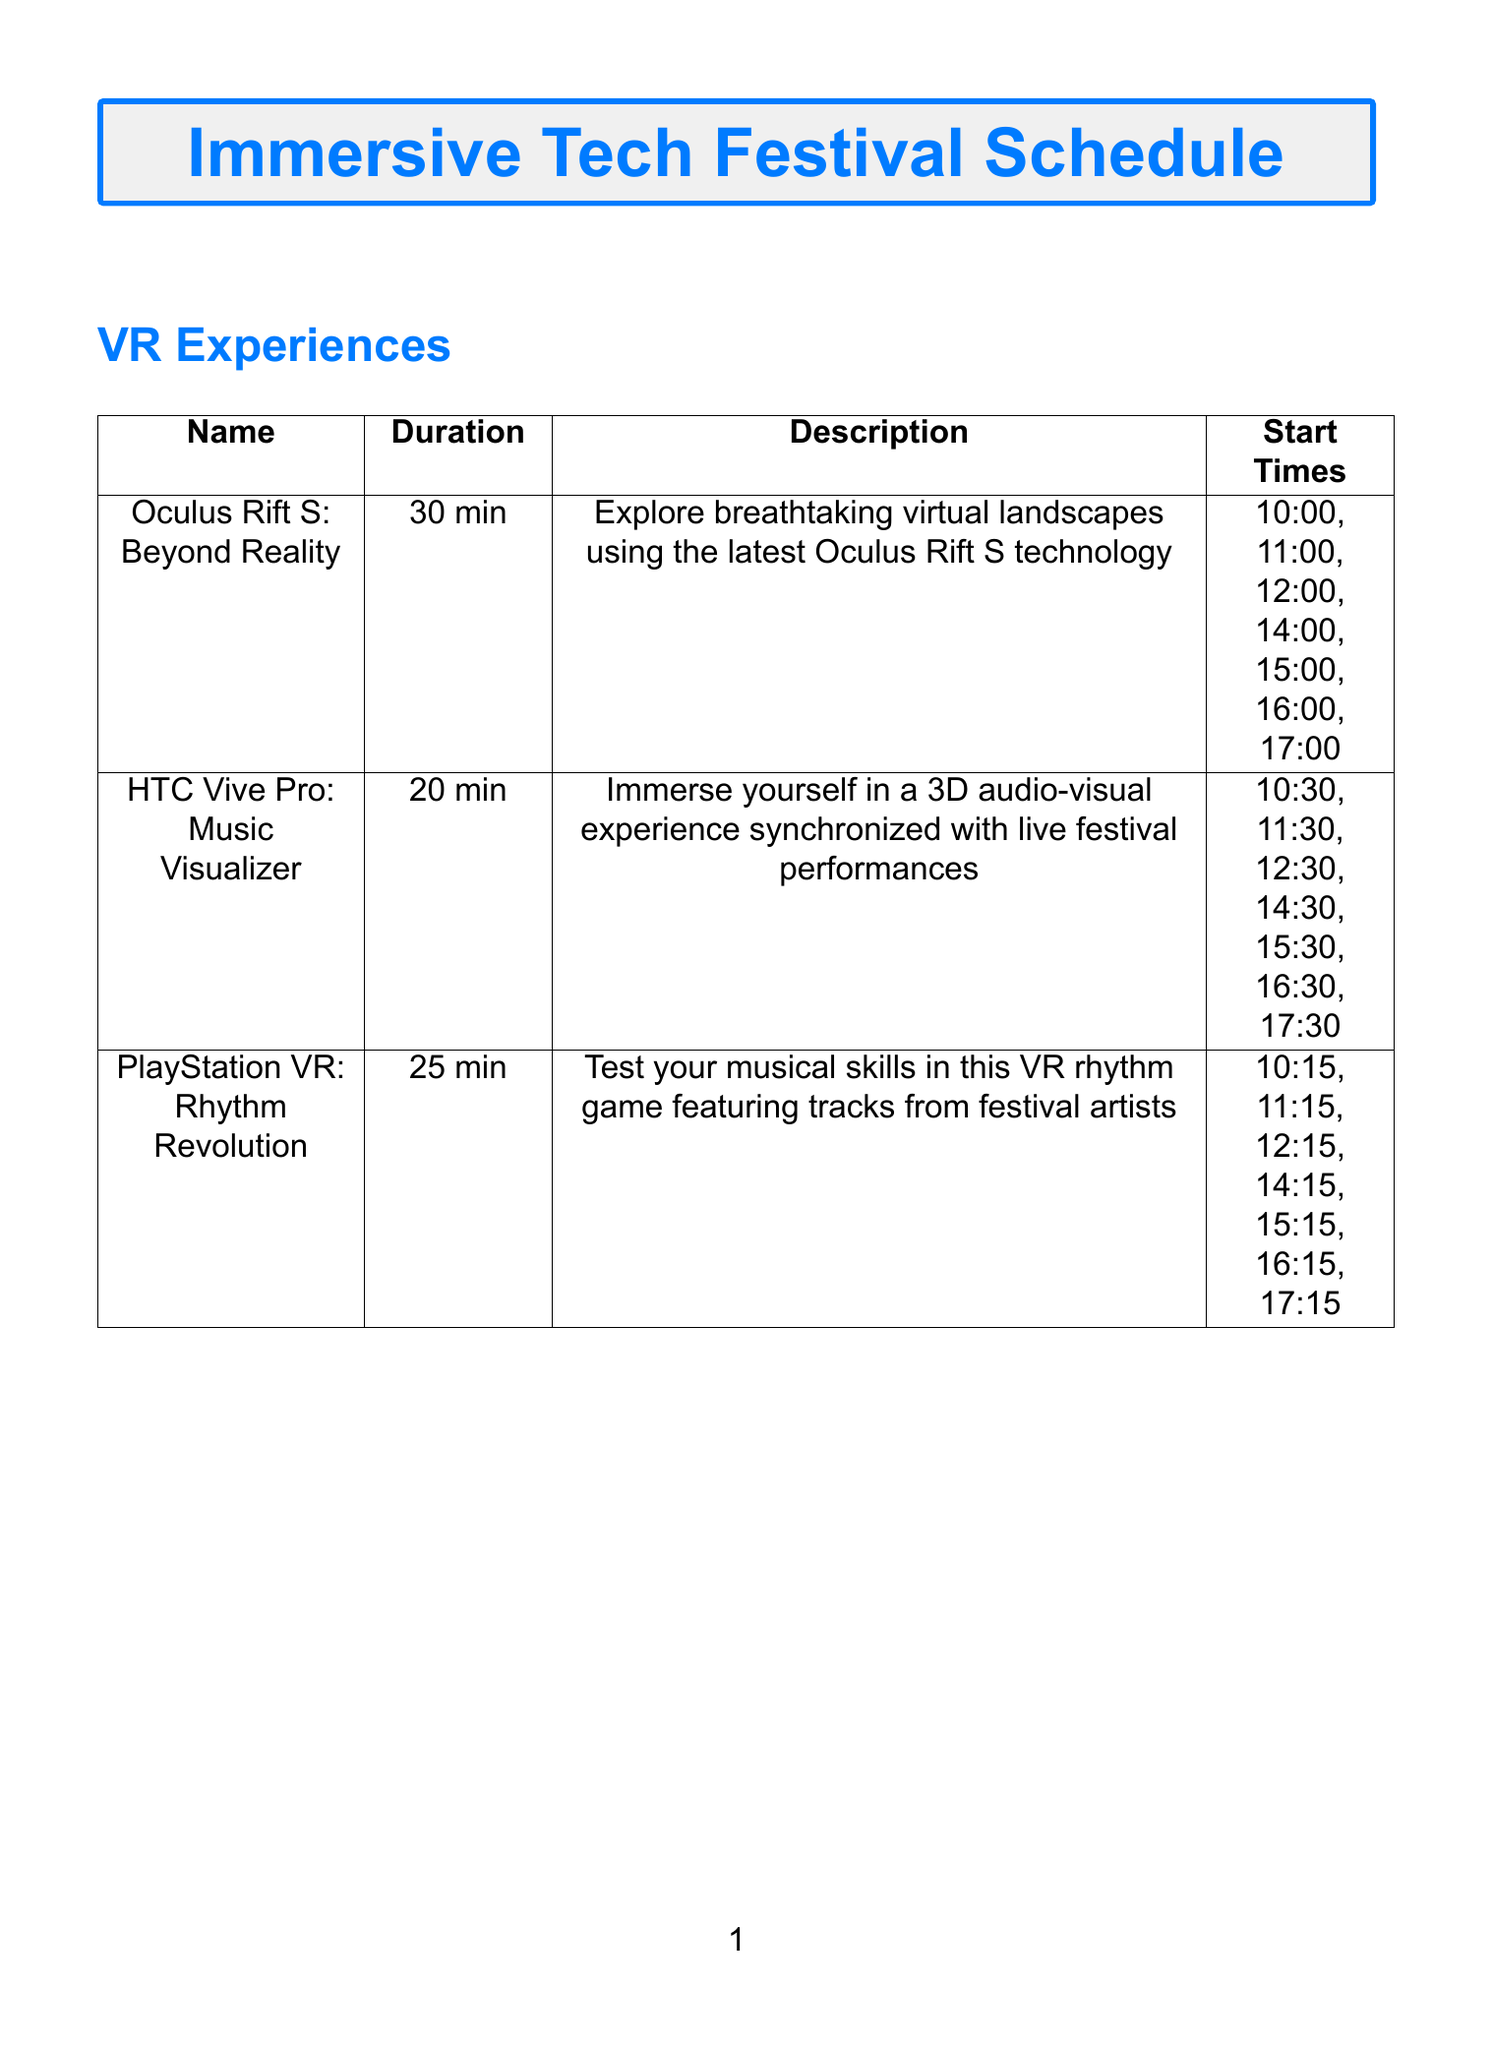What is the first VR experience listed? The first VR experience in the document is listed at the top of the "VR Experiences" section, which is "Oculus Rift S: Beyond Reality".
Answer: Oculus Rift S: Beyond Reality How long does the "HTC Vive Pro: Music Visualizer" last? The duration for the “HTC Vive Pro: Music Visualizer” is mentioned clearly in the respective table under the "Duration" column.
Answer: 20 min What time does the "Festival GO" AR game start? The start time for the "Festival GO" AR game is specified at the beginning of the description.
Answer: 10:00 What is the capacity for the "Stage Invaders" AR game? The capacity is noted in the table, which lists how many participants can join the "Stage Invaders" session.
Answer: 8 How many VR experiences have start times at 15:00? By counting the start times listed in the "VR Experiences" section for the specific hour of 15:00, the total can be deduced.
Answer: 3 What is the name of the special event scheduled at 20:00? The only special event start time at 20:00 is explicitly stated in the "Special Events" section.
Answer: VR Concert: The Glitch Mob Live How many different AR games have sessions starting at 11:45? The "AR Games" section lists each session and the times, helping to identify how many games start at that time.
Answer: 2 Which VR experience has the shortest duration? By comparing the durations listed for each VR experience in the table, the shortest can be determined.
Answer: HTC Vive Pro: Music Visualizer What technology is used in the "Magic Leap: Soundscape Sculptor"? The technology is specified in the description for the "Magic Leap: Soundscape Sculptor" AR game.
Answer: Magic Leap One AR headsets 